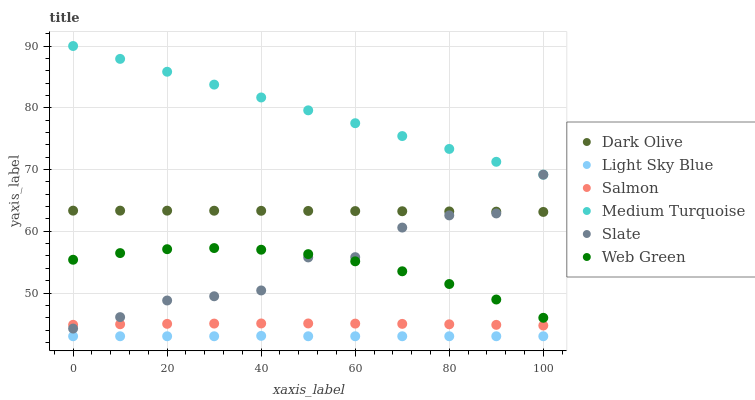Does Light Sky Blue have the minimum area under the curve?
Answer yes or no. Yes. Does Medium Turquoise have the maximum area under the curve?
Answer yes or no. Yes. Does Dark Olive have the minimum area under the curve?
Answer yes or no. No. Does Dark Olive have the maximum area under the curve?
Answer yes or no. No. Is Medium Turquoise the smoothest?
Answer yes or no. Yes. Is Slate the roughest?
Answer yes or no. Yes. Is Dark Olive the smoothest?
Answer yes or no. No. Is Dark Olive the roughest?
Answer yes or no. No. Does Light Sky Blue have the lowest value?
Answer yes or no. Yes. Does Dark Olive have the lowest value?
Answer yes or no. No. Does Medium Turquoise have the highest value?
Answer yes or no. Yes. Does Dark Olive have the highest value?
Answer yes or no. No. Is Dark Olive less than Medium Turquoise?
Answer yes or no. Yes. Is Dark Olive greater than Light Sky Blue?
Answer yes or no. Yes. Does Slate intersect Dark Olive?
Answer yes or no. Yes. Is Slate less than Dark Olive?
Answer yes or no. No. Is Slate greater than Dark Olive?
Answer yes or no. No. Does Dark Olive intersect Medium Turquoise?
Answer yes or no. No. 